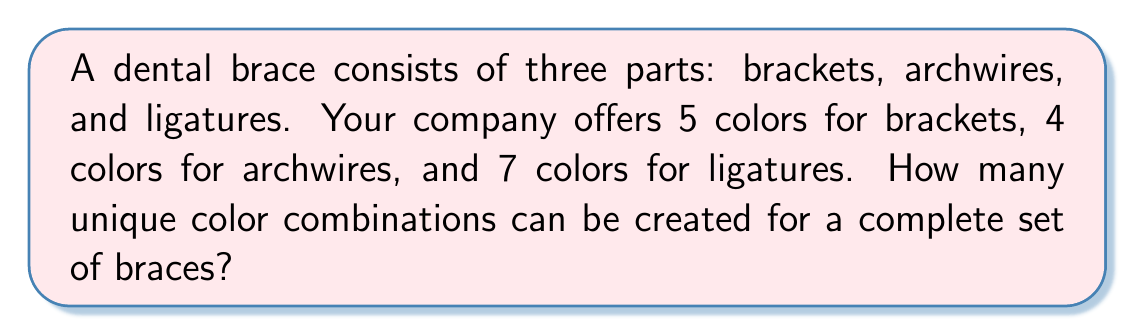Give your solution to this math problem. To solve this problem, we'll use the multiplication principle of counting. This principle states that if we have a sequence of independent choices, the total number of possible outcomes is the product of the number of possibilities for each choice.

In this case, we have three independent choices:

1. Color of brackets: 5 options
2. Color of archwires: 4 options
3. Color of ligatures: 7 options

Let's break it down step-by-step:

1) For the first choice (brackets), we have 5 options.

2) For each of these 5 bracket color choices, we have 4 options for the archwire color. This gives us $5 \times 4 = 20$ combinations of bracket and archwire colors.

3) For each of these 20 combinations, we have 7 options for the ligature color.

Therefore, the total number of unique color combinations is:

$$ 5 \times 4 \times 7 = 140 $$

This calculation can also be expressed as:

$$ \text{Number of combinations} = \text{Bracket colors} \times \text{Archwire colors} \times \text{Ligature colors} $$

$$ = 5 \times 4 \times 7 = 140 $$

Thus, there are 140 unique color combinations possible for a complete set of braces.
Answer: 140 